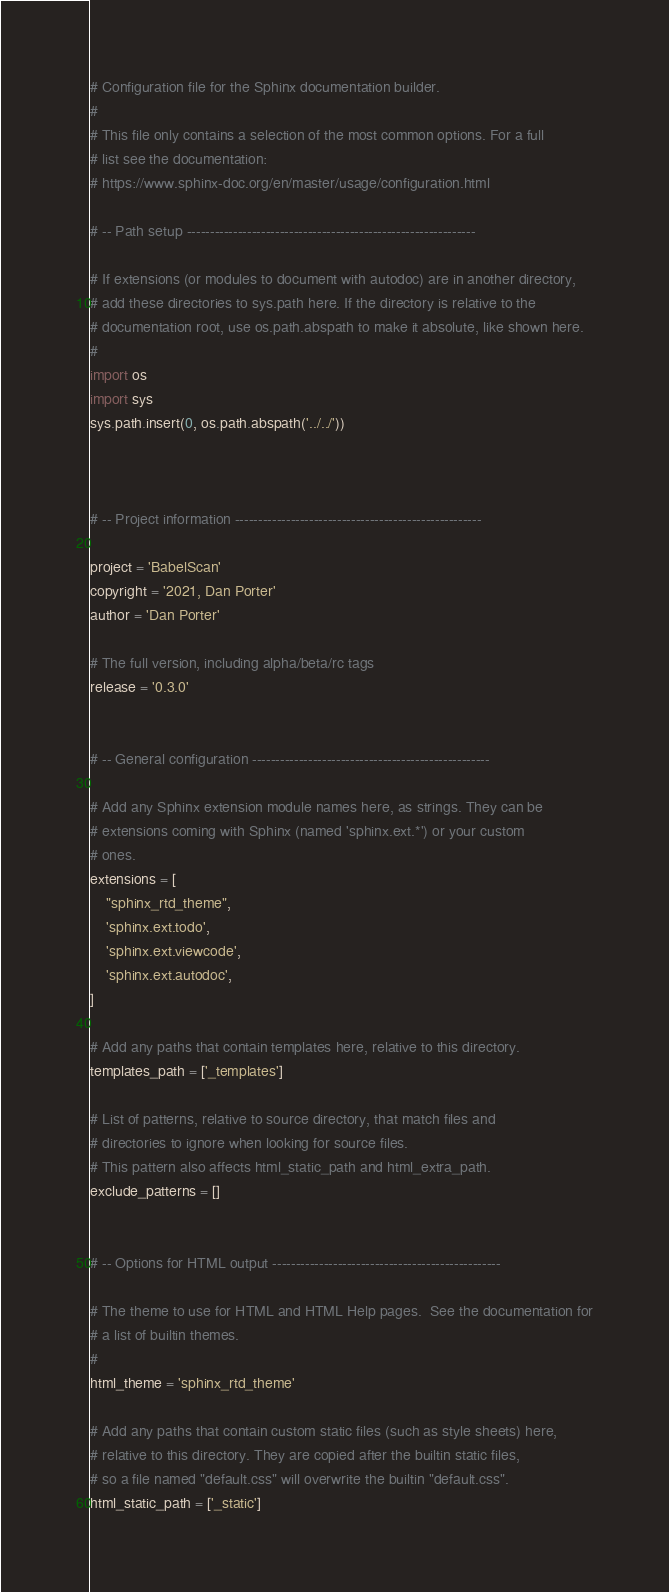Convert code to text. <code><loc_0><loc_0><loc_500><loc_500><_Python_># Configuration file for the Sphinx documentation builder.
#
# This file only contains a selection of the most common options. For a full
# list see the documentation:
# https://www.sphinx-doc.org/en/master/usage/configuration.html

# -- Path setup --------------------------------------------------------------

# If extensions (or modules to document with autodoc) are in another directory,
# add these directories to sys.path here. If the directory is relative to the
# documentation root, use os.path.abspath to make it absolute, like shown here.
#
import os
import sys
sys.path.insert(0, os.path.abspath('../../'))



# -- Project information -----------------------------------------------------

project = 'BabelScan'
copyright = '2021, Dan Porter'
author = 'Dan Porter'

# The full version, including alpha/beta/rc tags
release = '0.3.0'


# -- General configuration ---------------------------------------------------

# Add any Sphinx extension module names here, as strings. They can be
# extensions coming with Sphinx (named 'sphinx.ext.*') or your custom
# ones.
extensions = [
    "sphinx_rtd_theme",
    'sphinx.ext.todo',
    'sphinx.ext.viewcode',
    'sphinx.ext.autodoc',
]

# Add any paths that contain templates here, relative to this directory.
templates_path = ['_templates']

# List of patterns, relative to source directory, that match files and
# directories to ignore when looking for source files.
# This pattern also affects html_static_path and html_extra_path.
exclude_patterns = []


# -- Options for HTML output -------------------------------------------------

# The theme to use for HTML and HTML Help pages.  See the documentation for
# a list of builtin themes.
#
html_theme = 'sphinx_rtd_theme'

# Add any paths that contain custom static files (such as style sheets) here,
# relative to this directory. They are copied after the builtin static files,
# so a file named "default.css" will overwrite the builtin "default.css".
html_static_path = ['_static']</code> 